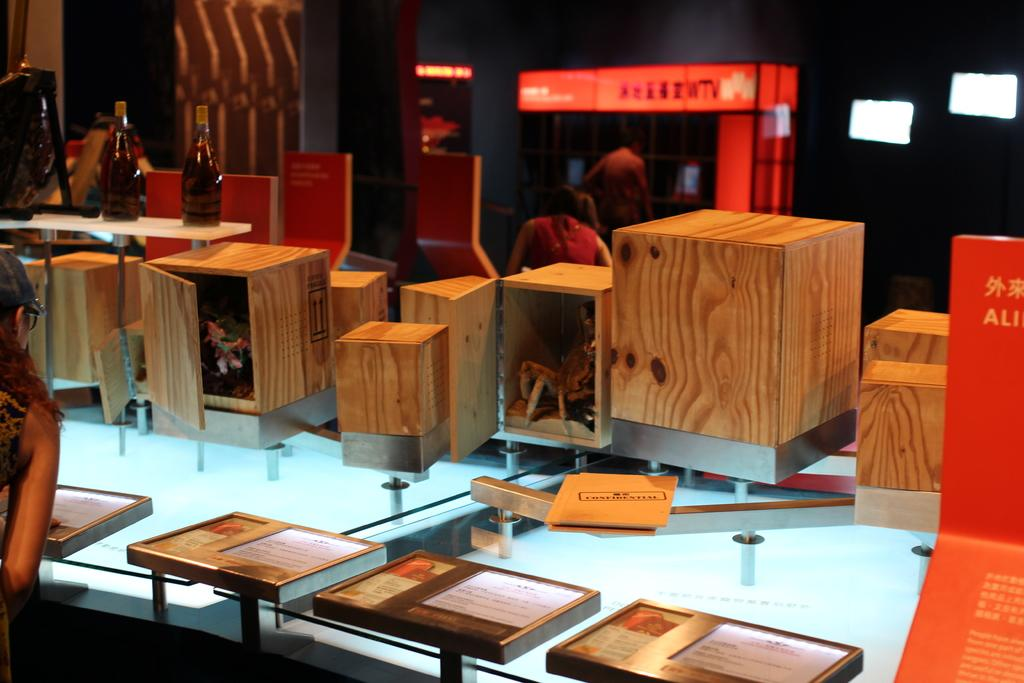Who is the main subject in the image? There is a woman in the image. What is the woman doing in the image? The woman is standing in front of a table. What objects are on the table in the image? There are boxes and two bottles on the table. Are there any other people visible in the image? Yes, there are two more persons in the background of the image. What can be seen in the background of the image besides the people? There are lights visible in the background of the image. What type of organization is the woman representing in the image? There is no indication in the image of any organization the woman might be representing. 